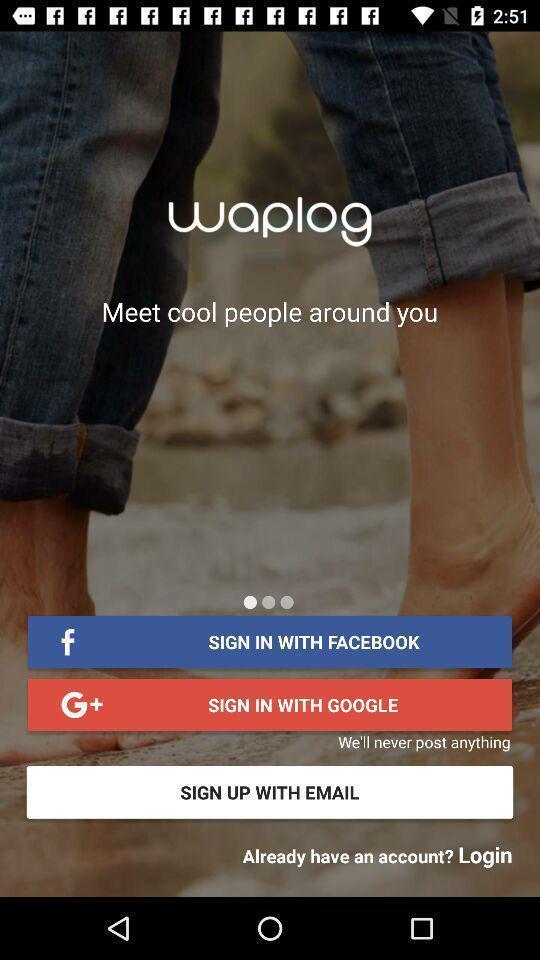Tell me about the visual elements in this screen capture. Signing up page of a dating app. 